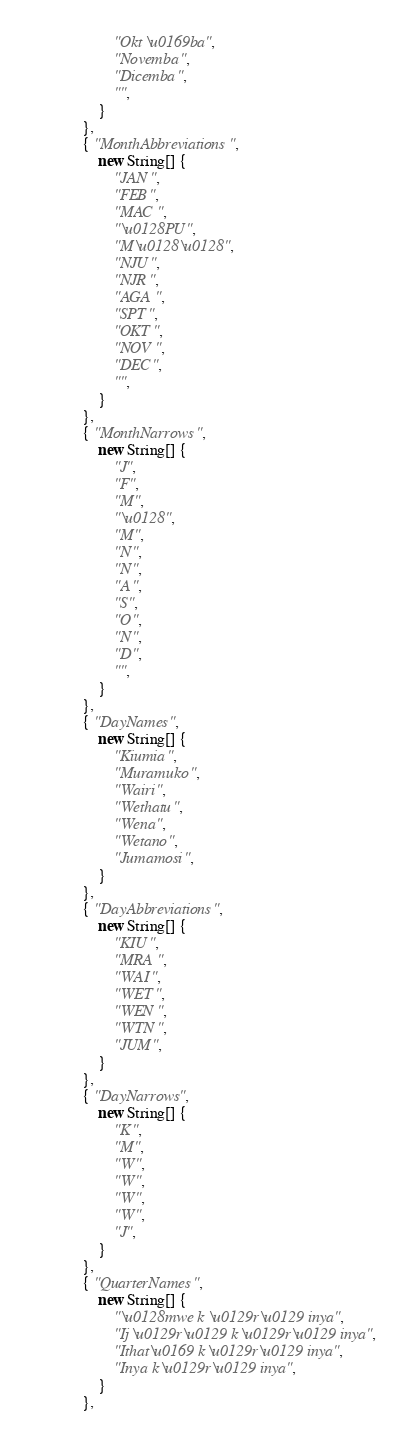Convert code to text. <code><loc_0><loc_0><loc_500><loc_500><_Java_>                    "Okt\u0169ba",
                    "Novemba",
                    "Dicemba",
                    "",
                }
            },
            { "MonthAbbreviations",
                new String[] {
                    "JAN",
                    "FEB",
                    "MAC",
                    "\u0128PU",
                    "M\u0128\u0128",
                    "NJU",
                    "NJR",
                    "AGA",
                    "SPT",
                    "OKT",
                    "NOV",
                    "DEC",
                    "",
                }
            },
            { "MonthNarrows",
                new String[] {
                    "J",
                    "F",
                    "M",
                    "\u0128",
                    "M",
                    "N",
                    "N",
                    "A",
                    "S",
                    "O",
                    "N",
                    "D",
                    "",
                }
            },
            { "DayNames",
                new String[] {
                    "Kiumia",
                    "Muramuko",
                    "Wairi",
                    "Wethatu",
                    "Wena",
                    "Wetano",
                    "Jumamosi",
                }
            },
            { "DayAbbreviations",
                new String[] {
                    "KIU",
                    "MRA",
                    "WAI",
                    "WET",
                    "WEN",
                    "WTN",
                    "JUM",
                }
            },
            { "DayNarrows",
                new String[] {
                    "K",
                    "M",
                    "W",
                    "W",
                    "W",
                    "W",
                    "J",
                }
            },
            { "QuarterNames",
                new String[] {
                    "\u0128mwe k\u0129r\u0129 inya",
                    "Ij\u0129r\u0129 k\u0129r\u0129 inya",
                    "Ithat\u0169 k\u0129r\u0129 inya",
                    "Inya k\u0129r\u0129 inya",
                }
            },</code> 